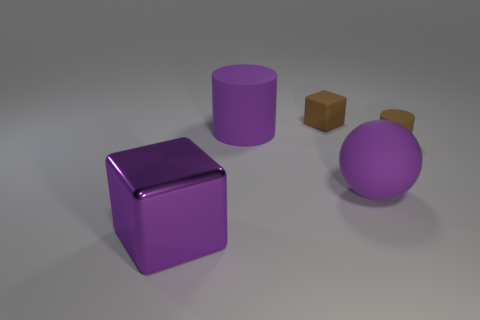The large cylinder that is the same material as the sphere is what color? purple 